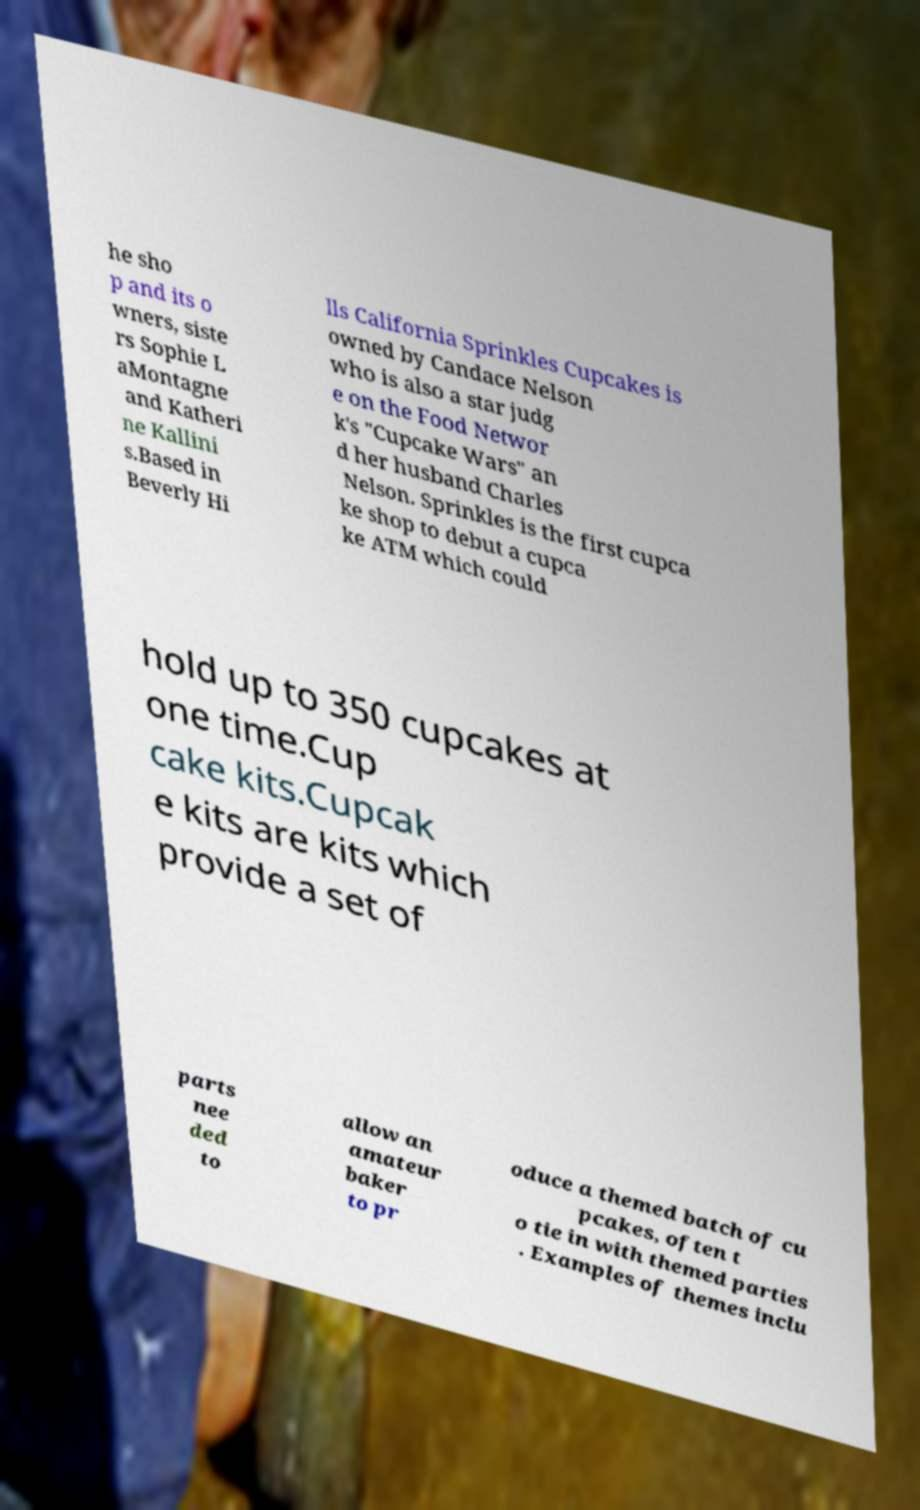Please identify and transcribe the text found in this image. he sho p and its o wners, siste rs Sophie L aMontagne and Katheri ne Kallini s.Based in Beverly Hi lls California Sprinkles Cupcakes is owned by Candace Nelson who is also a star judg e on the Food Networ k's "Cupcake Wars" an d her husband Charles Nelson. Sprinkles is the first cupca ke shop to debut a cupca ke ATM which could hold up to 350 cupcakes at one time.Cup cake kits.Cupcak e kits are kits which provide a set of parts nee ded to allow an amateur baker to pr oduce a themed batch of cu pcakes, often t o tie in with themed parties . Examples of themes inclu 